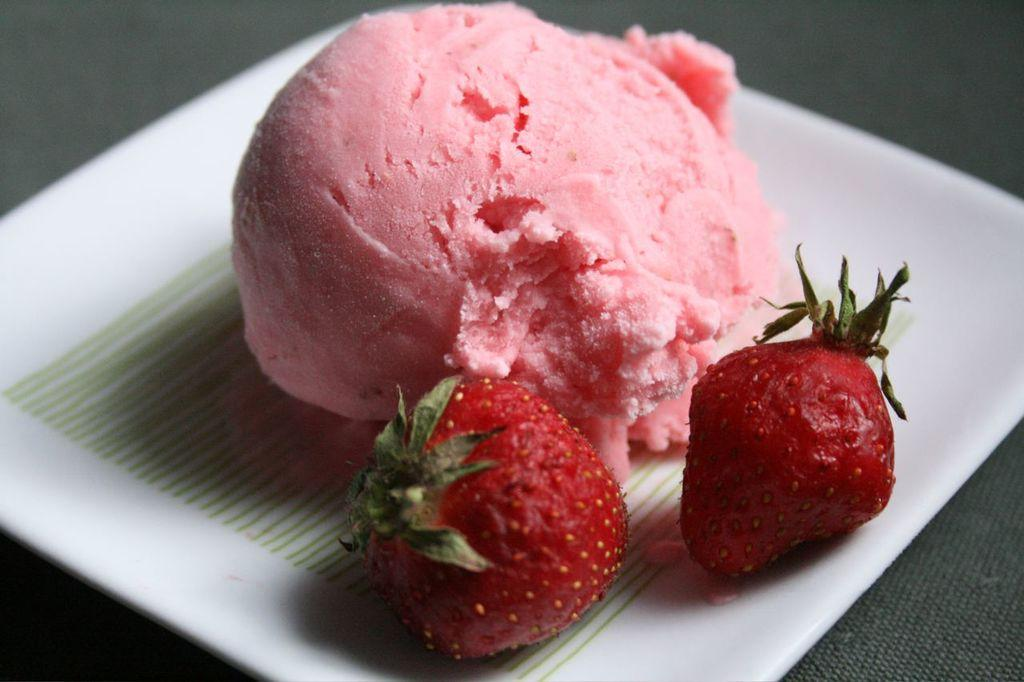What types of food items can be seen in the image? There are two fruits and an ice cream in the image. How are the food items arranged in the image? The items are on a plate. Can you describe the setting of the image? The image may have been taken in a room. How many dogs are visible in the image? There are no dogs present in the image. What type of twist can be seen in the image? There is no twist visible in the image. 